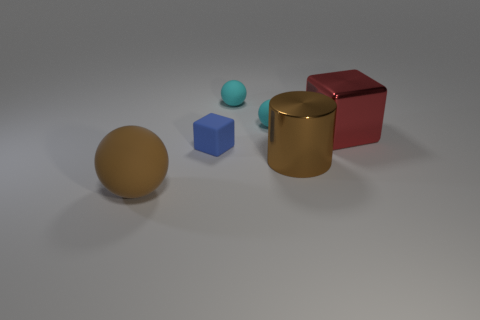Subtract all tiny cyan balls. How many balls are left? 1 Subtract 1 balls. How many balls are left? 2 Add 2 small green matte cylinders. How many objects exist? 8 Subtract all cylinders. How many objects are left? 5 Subtract all purple cylinders. Subtract all purple balls. How many cylinders are left? 1 Subtract all yellow cylinders. How many brown spheres are left? 1 Subtract all small blue matte blocks. Subtract all large cylinders. How many objects are left? 4 Add 2 small cyan rubber spheres. How many small cyan rubber spheres are left? 4 Add 3 small balls. How many small balls exist? 5 Subtract all brown balls. How many balls are left? 2 